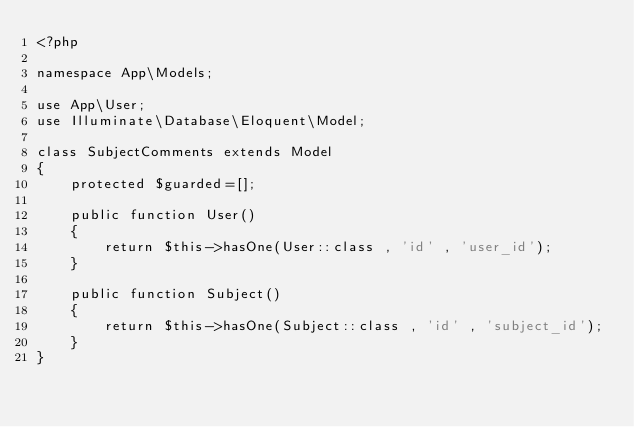<code> <loc_0><loc_0><loc_500><loc_500><_PHP_><?php

namespace App\Models;

use App\User;
use Illuminate\Database\Eloquent\Model;

class SubjectComments extends Model
{
    protected $guarded=[];

    public function User()
    {
        return $this->hasOne(User::class , 'id' , 'user_id');
    }

    public function Subject()
    {
        return $this->hasOne(Subject::class , 'id' , 'subject_id');
    }
}
</code> 